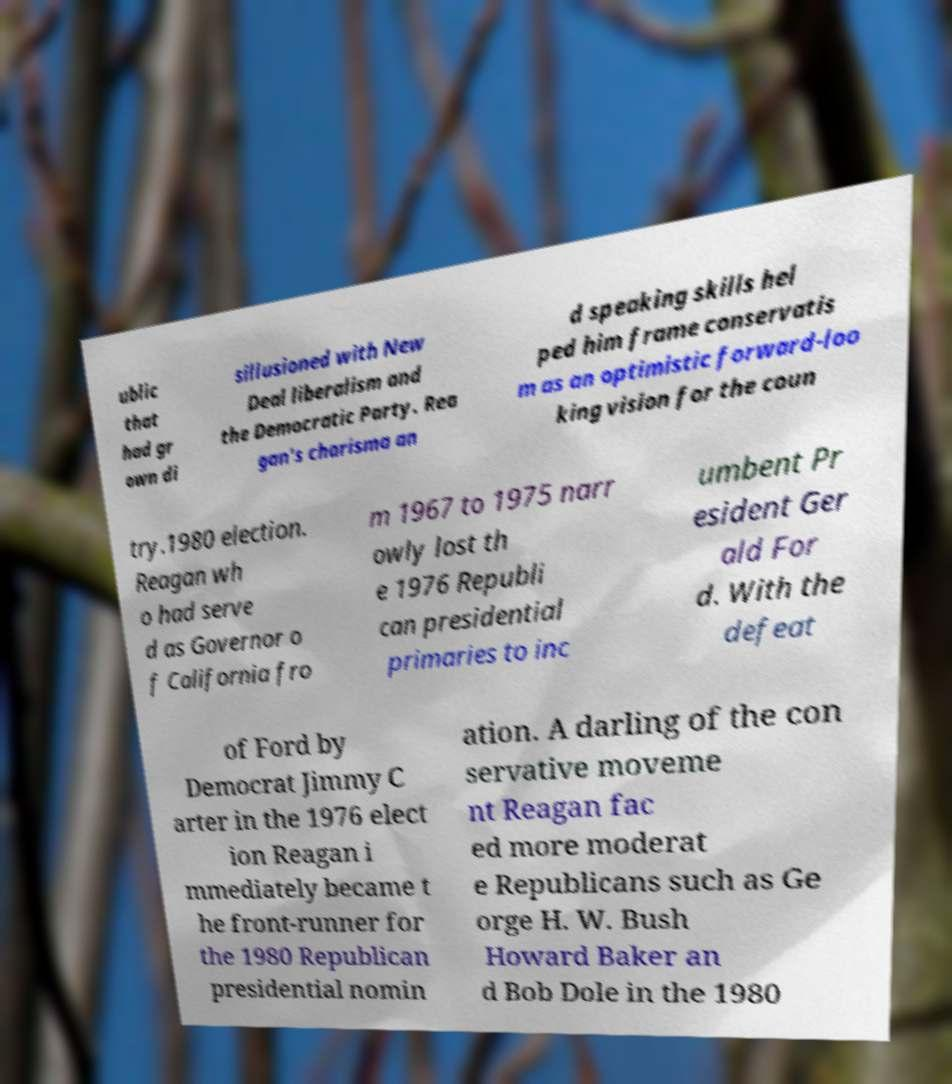Please identify and transcribe the text found in this image. ublic that had gr own di sillusioned with New Deal liberalism and the Democratic Party. Rea gan's charisma an d speaking skills hel ped him frame conservatis m as an optimistic forward-loo king vision for the coun try.1980 election. Reagan wh o had serve d as Governor o f California fro m 1967 to 1975 narr owly lost th e 1976 Republi can presidential primaries to inc umbent Pr esident Ger ald For d. With the defeat of Ford by Democrat Jimmy C arter in the 1976 elect ion Reagan i mmediately became t he front-runner for the 1980 Republican presidential nomin ation. A darling of the con servative moveme nt Reagan fac ed more moderat e Republicans such as Ge orge H. W. Bush Howard Baker an d Bob Dole in the 1980 